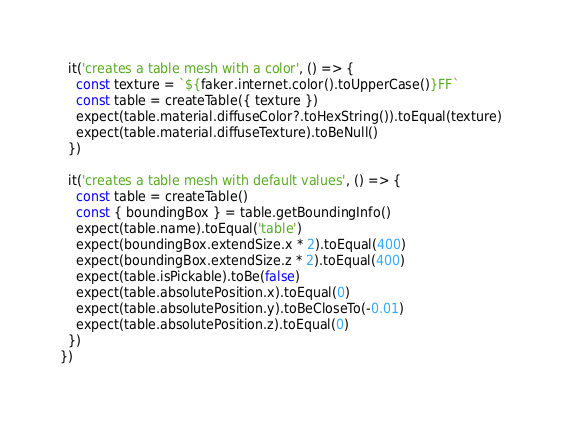Convert code to text. <code><loc_0><loc_0><loc_500><loc_500><_JavaScript_>
  it('creates a table mesh with a color', () => {
    const texture = `${faker.internet.color().toUpperCase()}FF`
    const table = createTable({ texture })
    expect(table.material.diffuseColor?.toHexString()).toEqual(texture)
    expect(table.material.diffuseTexture).toBeNull()
  })

  it('creates a table mesh with default values', () => {
    const table = createTable()
    const { boundingBox } = table.getBoundingInfo()
    expect(table.name).toEqual('table')
    expect(boundingBox.extendSize.x * 2).toEqual(400)
    expect(boundingBox.extendSize.z * 2).toEqual(400)
    expect(table.isPickable).toBe(false)
    expect(table.absolutePosition.x).toEqual(0)
    expect(table.absolutePosition.y).toBeCloseTo(-0.01)
    expect(table.absolutePosition.z).toEqual(0)
  })
})
</code> 